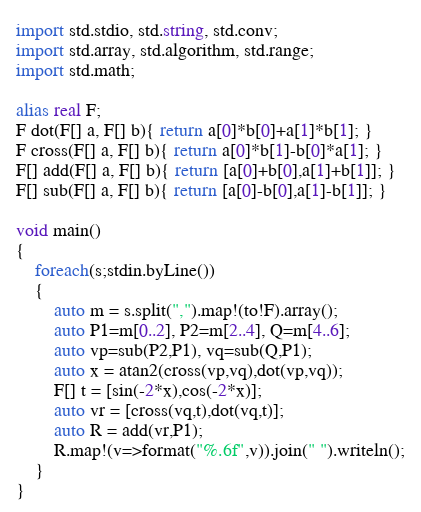Convert code to text. <code><loc_0><loc_0><loc_500><loc_500><_D_>import std.stdio, std.string, std.conv;
import std.array, std.algorithm, std.range;
import std.math;

alias real F;
F dot(F[] a, F[] b){ return a[0]*b[0]+a[1]*b[1]; }
F cross(F[] a, F[] b){ return a[0]*b[1]-b[0]*a[1]; }
F[] add(F[] a, F[] b){ return [a[0]+b[0],a[1]+b[1]]; }
F[] sub(F[] a, F[] b){ return [a[0]-b[0],a[1]-b[1]]; }

void main()
{
    foreach(s;stdin.byLine())
    {
        auto m = s.split(",").map!(to!F).array();
        auto P1=m[0..2], P2=m[2..4], Q=m[4..6];
        auto vp=sub(P2,P1), vq=sub(Q,P1);
        auto x = atan2(cross(vp,vq),dot(vp,vq));
        F[] t = [sin(-2*x),cos(-2*x)];
        auto vr = [cross(vq,t),dot(vq,t)];
        auto R = add(vr,P1);
        R.map!(v=>format("%.6f",v)).join(" ").writeln();
    }
}</code> 